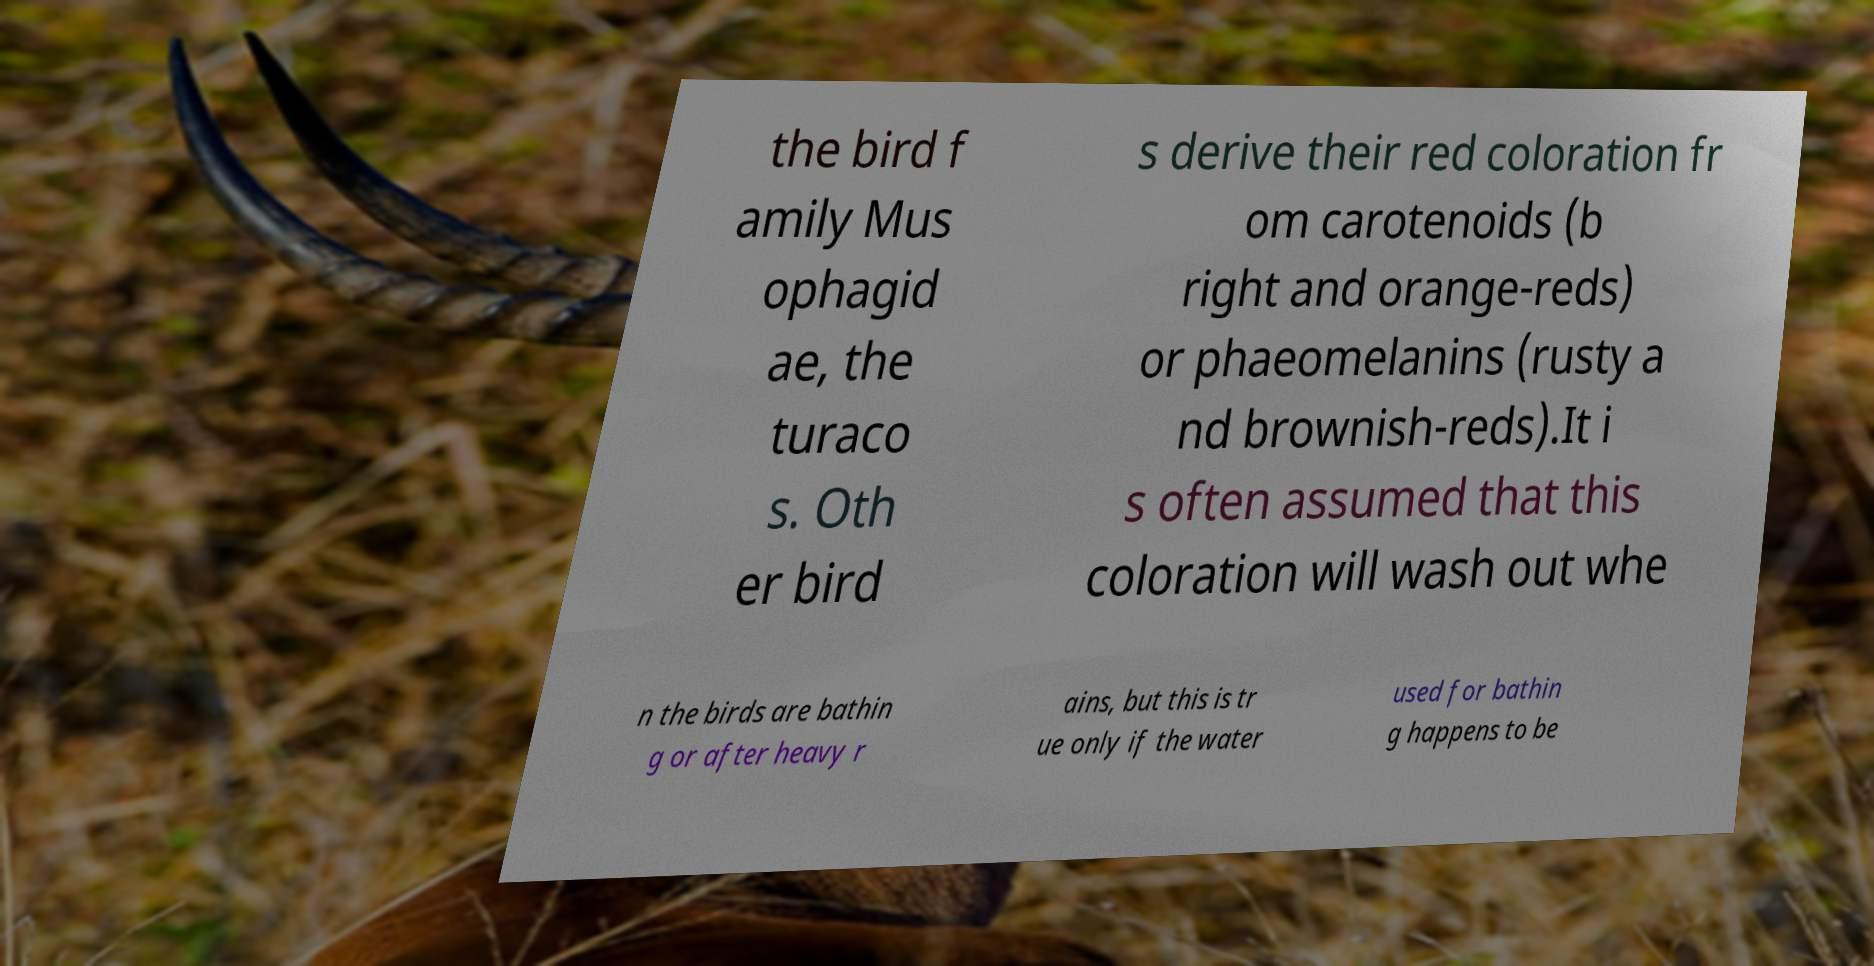For documentation purposes, I need the text within this image transcribed. Could you provide that? the bird f amily Mus ophagid ae, the turaco s. Oth er bird s derive their red coloration fr om carotenoids (b right and orange-reds) or phaeomelanins (rusty a nd brownish-reds).It i s often assumed that this coloration will wash out whe n the birds are bathin g or after heavy r ains, but this is tr ue only if the water used for bathin g happens to be 